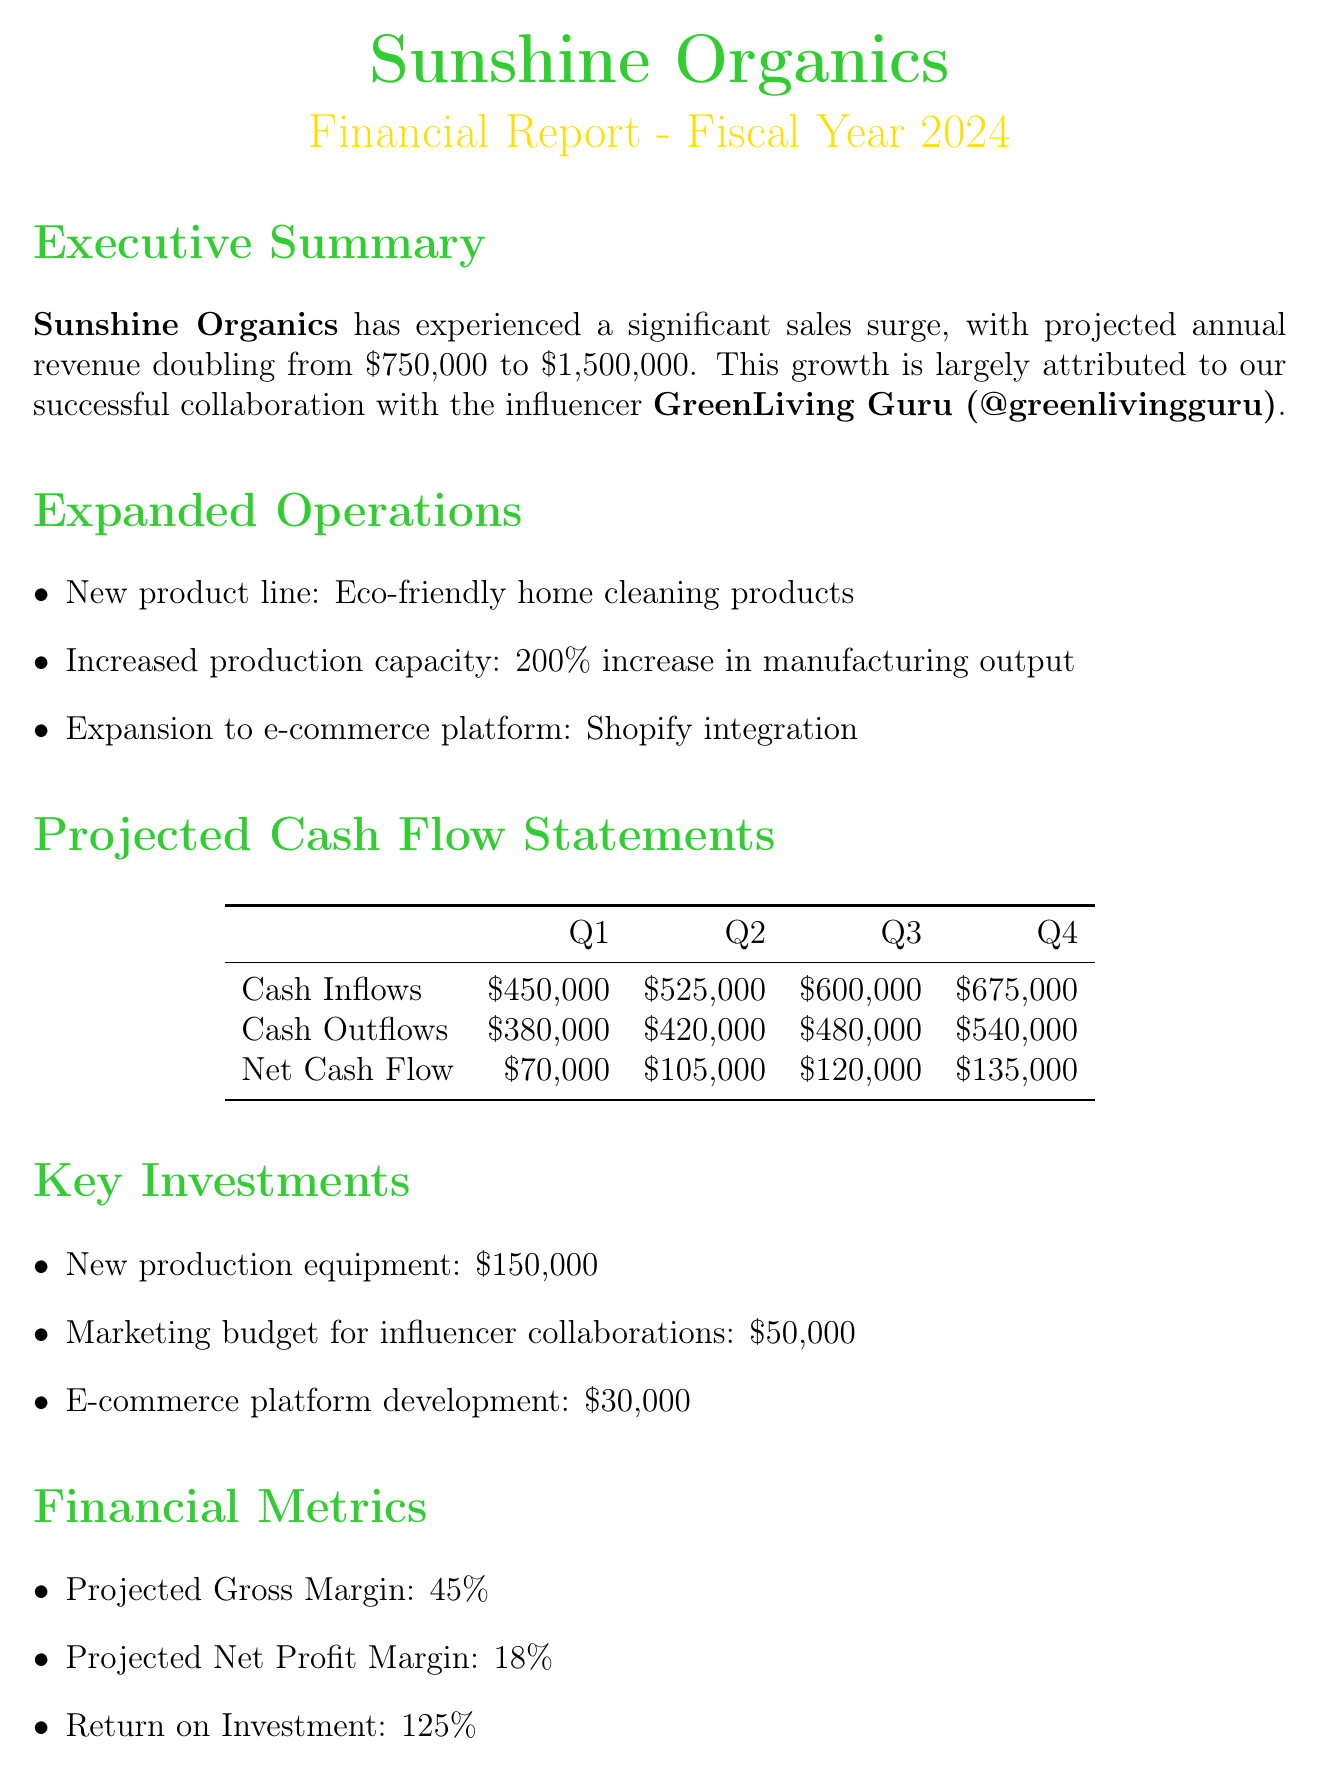What is the current annual revenue? The current annual revenue is specified in the document as $750,000.
Answer: $750,000 What is the projected annual revenue? The projected annual revenue is stated in the document as $1,500,000.
Answer: $1,500,000 Who is the influencer partner? The influencer partner is mentioned in the document as GreenLiving Guru (@greenlivingguru).
Answer: GreenLiving Guru (@greenlivingguru) What is the cash inflow for Q2? The cash inflow for Q2 is detailed in the projected cash flow statements as $525,000.
Answer: $525,000 What is the net cash flow for Q4? The net cash flow for Q4 is provided in the cash flow statements, which is $135,000.
Answer: $135,000 What is the total cost of key investments? The total cost of key investments can be calculated from the document as $150,000 + $50,000 + $30,000 = $230,000.
Answer: $230,000 What is the projected gross margin? The projected gross margin is given in the document as 45%.
Answer: 45% What risk factor relates to marketing regulations? The risk factor related to marketing regulations is specified as "Changes in influencer marketing regulations".
Answer: Changes in influencer marketing regulations How many product lines are expanded? The document states that there is one new product line: eco-friendly home cleaning products.
Answer: One 